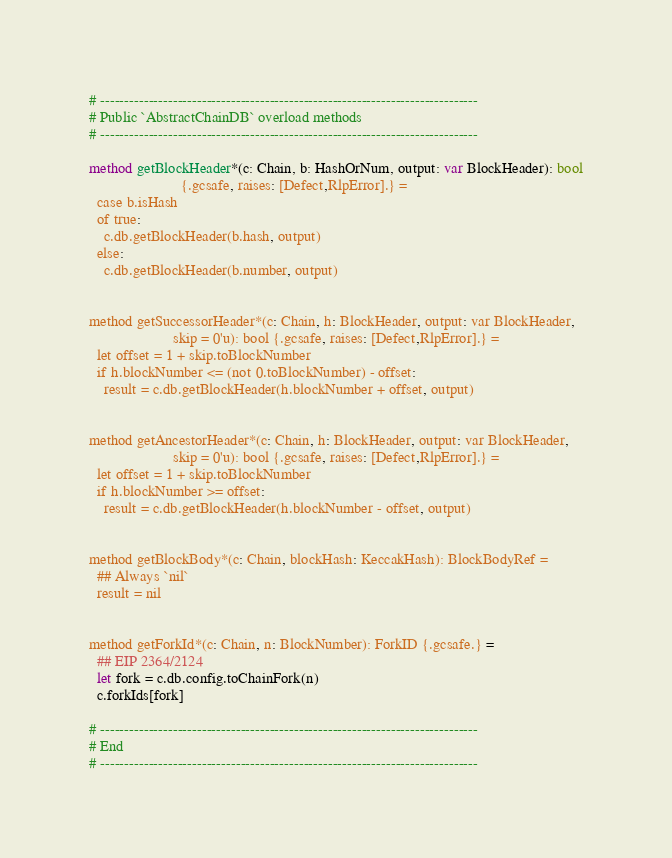<code> <loc_0><loc_0><loc_500><loc_500><_Nim_>
# ------------------------------------------------------------------------------
# Public `AbstractChainDB` overload methods
# ------------------------------------------------------------------------------

method getBlockHeader*(c: Chain, b: HashOrNum, output: var BlockHeader): bool
                        {.gcsafe, raises: [Defect,RlpError].} =
  case b.isHash
  of true:
    c.db.getBlockHeader(b.hash, output)
  else:
    c.db.getBlockHeader(b.number, output)


method getSuccessorHeader*(c: Chain, h: BlockHeader, output: var BlockHeader,
                      skip = 0'u): bool {.gcsafe, raises: [Defect,RlpError].} =
  let offset = 1 + skip.toBlockNumber
  if h.blockNumber <= (not 0.toBlockNumber) - offset:
    result = c.db.getBlockHeader(h.blockNumber + offset, output)


method getAncestorHeader*(c: Chain, h: BlockHeader, output: var BlockHeader,
                      skip = 0'u): bool {.gcsafe, raises: [Defect,RlpError].} =
  let offset = 1 + skip.toBlockNumber
  if h.blockNumber >= offset:
    result = c.db.getBlockHeader(h.blockNumber - offset, output)


method getBlockBody*(c: Chain, blockHash: KeccakHash): BlockBodyRef =
  ## Always `nil`
  result = nil


method getForkId*(c: Chain, n: BlockNumber): ForkID {.gcsafe.} =
  ## EIP 2364/2124
  let fork = c.db.config.toChainFork(n)
  c.forkIds[fork]

# ------------------------------------------------------------------------------
# End
# ------------------------------------------------------------------------------
</code> 